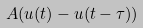<formula> <loc_0><loc_0><loc_500><loc_500>A ( u ( t ) - u ( t - \tau ) )</formula> 